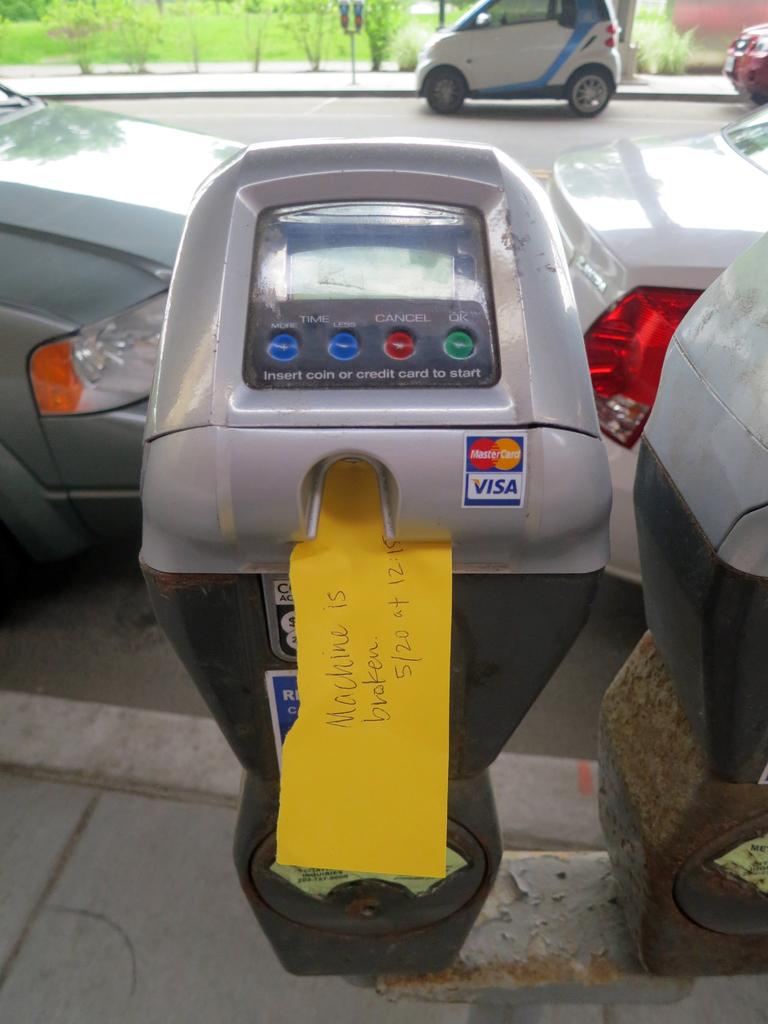<image>
Present a compact description of the photo's key features. A parking meter that was not working on May 20. 